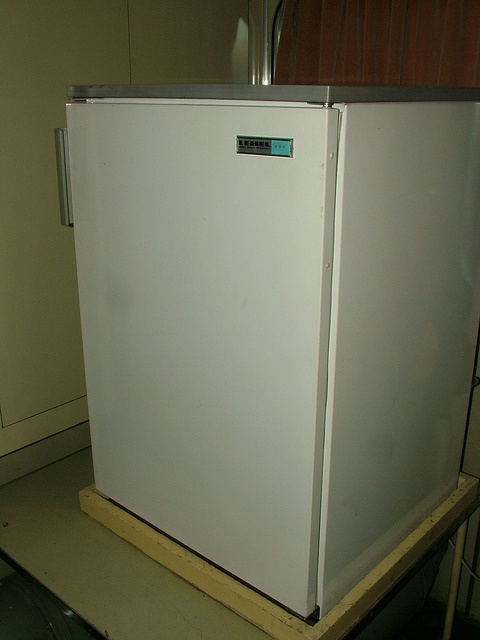Describe the objects in this image and their specific colors. I can see refrigerator in darkgreen, darkgray, and gray tones and refrigerator in darkgreen, gray, and darkgray tones in this image. 